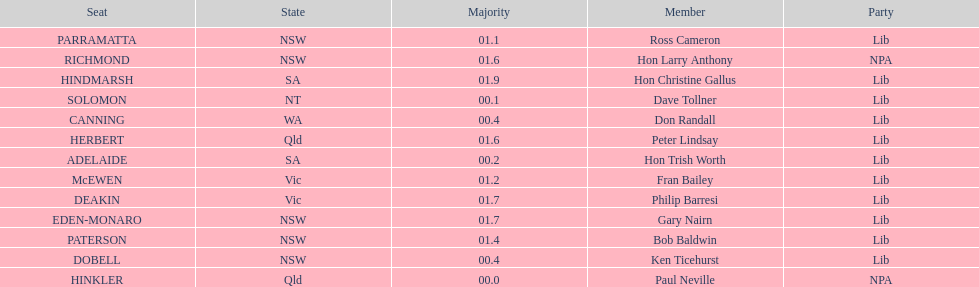How many states were represented in the seats? 6. 